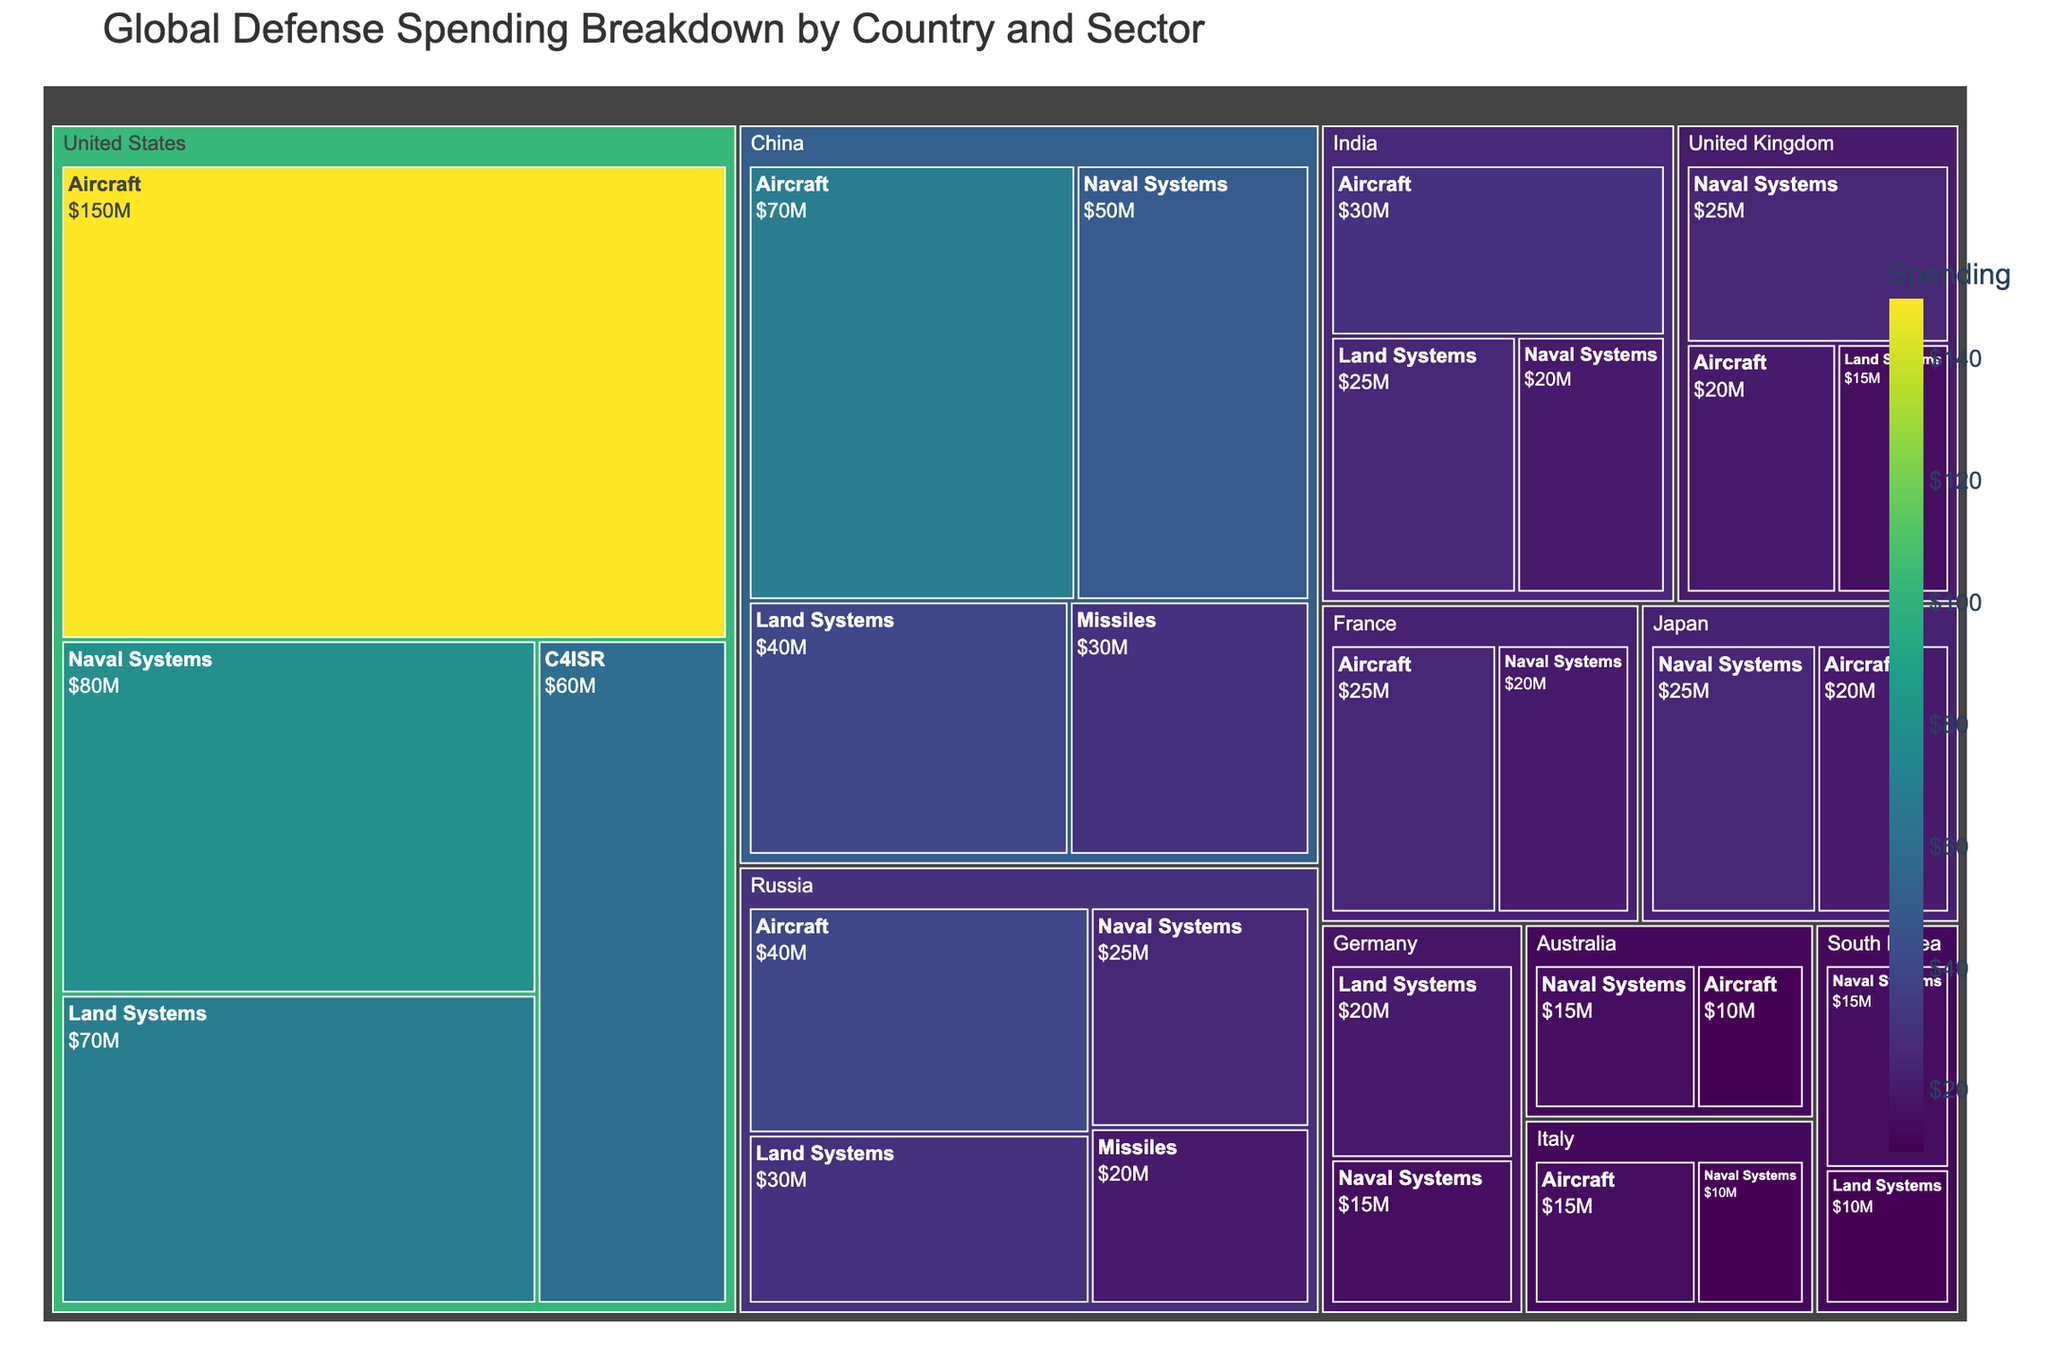What's the total defense spending for the United States? The treemap shows the breakdown of spending by country and sector. For the United States, sum the spending values for all sectors: 150 (Aircraft) + 80 (Naval Systems) + 70 (Land Systems) + 60 (C4ISR).
Answer: 360 Which country spends the most on Aircraft? Identify the highest spending value for the Aircraft sector and its associated country: the United States spends 150, China 70, Russia 40, etc. The United States has the highest value.
Answer: United States How does China's total defense spending compare to Russia's? Calculate the total spending for China and Russia by summing their respective sectors: China (70 + 50 + 40 + 30) and Russia (40 + 30 + 25 + 20). Compare these totals.
Answer: China spends more Which sector does the United Kingdom invest the most in? For the United Kingdom, compare the spending values for each sector: Naval Systems (25), Aircraft (20), and Land Systems (15). Naval Systems has the highest value.
Answer: Naval Systems What's the combined defense spending in the Aircraft sector across all countries? Sum the spending values for the Aircraft sector from each country: United States (150) + China (70) + Russia (40) + United Kingdom (20) + India (30) + France (25) + Japan (20) + Italy (15) + Australia (10).
Answer: 380 Out of the provided countries, which one has the smallest defense spending in a single sector? Identify the smallest value among all sector spending across all countries. South Korea's Land Systems spending is 10, matched by Australia in the Naval Systems and Aircraft sectors.
Answer: South Korea / Australia What is the approximate total global defense spending according to the figure? Sum the spending values for all countries and sectors: the United States (360), China (190), Russia (115), United Kingdom (60), India (75), France (45), Germany (35), Japan (45), South Korea (25), Italy (25), Australia (25).
Answer: 1,000 Compare the spending on Naval Systems between France and Germany. Identify the spending on Naval Systems for France (20) and Germany (15), then compare the two values: France's spending is higher.
Answer: France spends more Which country spends the most on Land Systems? Compare the spending on Land Systems across all countries: United States (70), China (40), Russia (30), United Kingdom (15), India (25), Germany (20), South Korea (10). The United States spends the most.
Answer: United States 